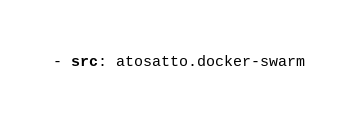Convert code to text. <code><loc_0><loc_0><loc_500><loc_500><_YAML_>
- src: atosatto.docker-swarm
</code> 